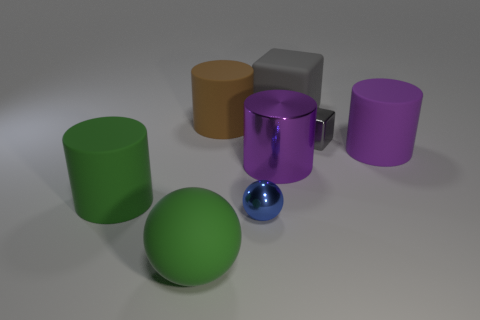Subtract all blue cylinders. Subtract all brown balls. How many cylinders are left? 4 Subtract all cubes. How many objects are left? 6 Subtract all big matte balls. Subtract all green spheres. How many objects are left? 6 Add 4 big green rubber cylinders. How many big green rubber cylinders are left? 5 Add 1 brown rubber objects. How many brown rubber objects exist? 2 Subtract 0 red cubes. How many objects are left? 8 